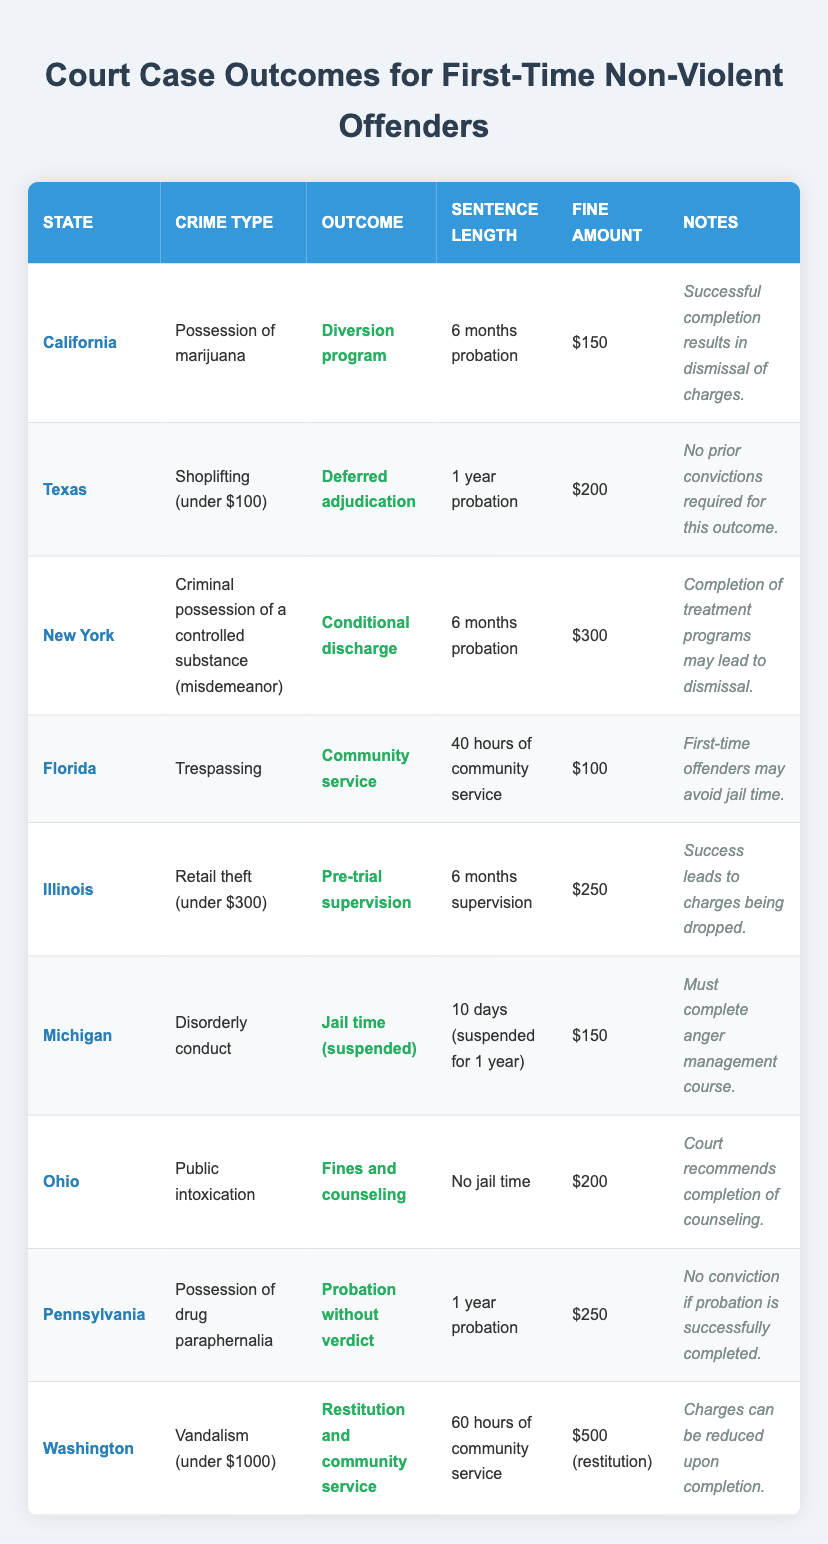What is the outcome for a first-time non-violent offender in California charged with possession of marijuana? The table shows that in California for possession of marijuana, the outcome is a "Diversion program."
Answer: Diversion program How long is the probation period for a first-time offender in Texas charged with shoplifting under $100? The table indicates that in Texas, the sentence length for shoplifting under $100 is "1 year probation."
Answer: 1 year probation What is the total fine amount for a first-time offender in Michigan charged with disorderly conduct? According to the table, the fine amount for disorderly conduct in Michigan is "$150."
Answer: $150 In which state can a first-time offender avoid jail time for a trespassing charge? The data shows that in Florida, first-time offenders for trespassing may avoid jail time as the sentence involves community service.
Answer: Florida What is the average fine amount for the crimes listed in the table? To find the average, sum the fines ($150 + $200 + $300 + $100 + $250 + $150 + $200 + $250 + $500) = $2100. There are 9 states listed, thus the average fine is $2100/9 = $233.33.
Answer: $233.33 Is it true that all states listed provide an opportunity for probation or alternative sentencing? Yes, all listed outcomes involve probation, community service, or alternative sentencing options for first-time non-violent offenders.
Answer: Yes If a first-time offender in New York completes treatment programs, what might happen to their charge? The table notes that completion of treatment programs in New York may lead to dismissal of charges.
Answer: Charges may be dismissed Which state has the highest fine amount for first-time non-violent offenders based on the table? Examining the fine amounts, Washington has the highest fine amount of $500 for restitution associated with vandalism.
Answer: Washington How many states offer community service as part of the sentencing for first-time non-violent offenders in the table? The table lists Florida and Washington as two states that mandate community service in their sentencing.
Answer: 2 states What condition must be met in Illinois for charges to be dropped after pre-trial supervision? The table states that success during the pre-trial supervision in Illinois leads to the charges being dropped.
Answer: Successful completion 